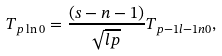Convert formula to latex. <formula><loc_0><loc_0><loc_500><loc_500>T _ { p \ln 0 } = \frac { ( s - n - 1 ) } { \sqrt { l p } } T _ { p - 1 l - 1 n 0 } ,</formula> 